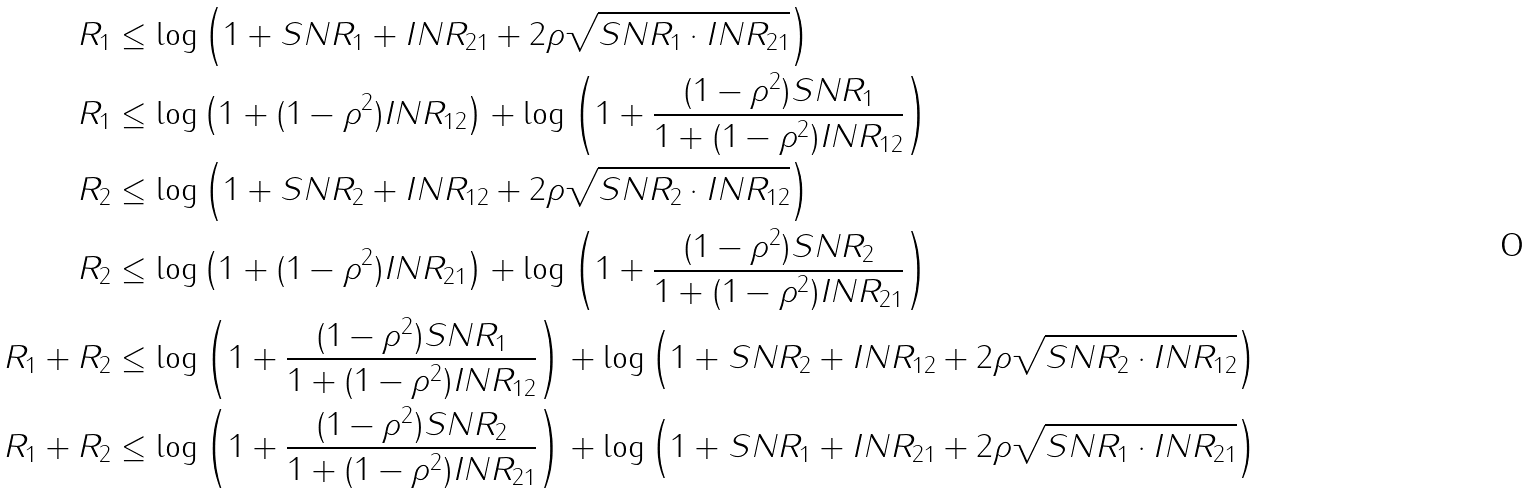<formula> <loc_0><loc_0><loc_500><loc_500>R _ { 1 } & \leq \log \left ( 1 + S N R _ { 1 } + I N R _ { 2 1 } + 2 \rho \sqrt { S N R _ { 1 } \cdot I N R _ { 2 1 } } \right ) \\ R _ { 1 } & \leq \log \left ( 1 + ( 1 - \rho ^ { 2 } ) I N R _ { 1 2 } \right ) + \log \left ( 1 + \frac { ( 1 - \rho ^ { 2 } ) S N R _ { 1 } } { 1 + ( 1 - \rho ^ { 2 } ) I N R _ { 1 2 } } \right ) \\ R _ { 2 } & \leq \log \left ( 1 + S N R _ { 2 } + I N R _ { 1 2 } + 2 \rho \sqrt { S N R _ { 2 } \cdot I N R _ { 1 2 } } \right ) \\ R _ { 2 } & \leq \log \left ( 1 + ( 1 - \rho ^ { 2 } ) I N R _ { 2 1 } \right ) + \log \left ( 1 + \frac { ( 1 - \rho ^ { 2 } ) S N R _ { 2 } } { 1 + ( 1 - \rho ^ { 2 } ) I N R _ { 2 1 } } \right ) \\ R _ { 1 } + R _ { 2 } & \leq \log \left ( 1 + \frac { ( 1 - \rho ^ { 2 } ) S N R _ { 1 } } { 1 + ( 1 - \rho ^ { 2 } ) I N R _ { 1 2 } } \right ) + \log \left ( 1 + S N R _ { 2 } + I N R _ { 1 2 } + 2 \rho \sqrt { S N R _ { 2 } \cdot I N R _ { 1 2 } } \right ) \\ R _ { 1 } + R _ { 2 } & \leq \log \left ( 1 + \frac { ( 1 - \rho ^ { 2 } ) S N R _ { 2 } } { 1 + ( 1 - \rho ^ { 2 } ) I N R _ { 2 1 } } \right ) + \log \left ( 1 + S N R _ { 1 } + I N R _ { 2 1 } + 2 \rho \sqrt { S N R _ { 1 } \cdot I N R _ { 2 1 } } \right )</formula> 